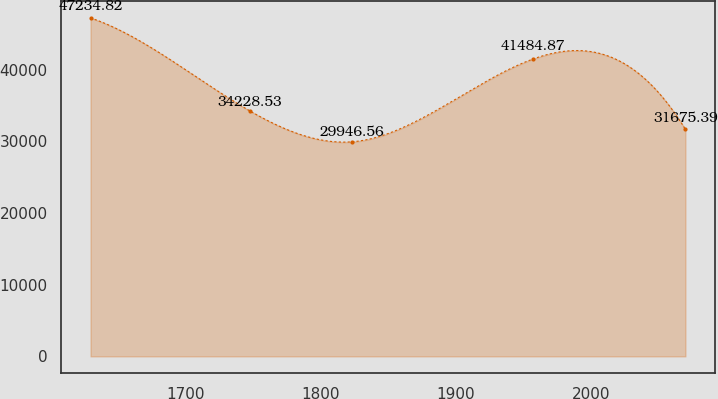Convert chart. <chart><loc_0><loc_0><loc_500><loc_500><line_chart><ecel><fcel>Unnamed: 1<nl><fcel>1629.96<fcel>47234.8<nl><fcel>1748.03<fcel>34228.5<nl><fcel>1823.33<fcel>29946.6<nl><fcel>1956.86<fcel>41484.9<nl><fcel>2069.78<fcel>31675.4<nl></chart> 